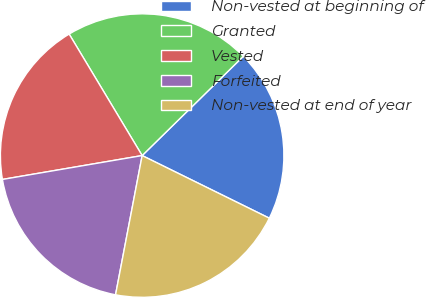Convert chart. <chart><loc_0><loc_0><loc_500><loc_500><pie_chart><fcel>Non-vested at beginning of<fcel>Granted<fcel>Vested<fcel>Forfeited<fcel>Non-vested at end of year<nl><fcel>19.63%<fcel>21.26%<fcel>19.08%<fcel>19.3%<fcel>20.72%<nl></chart> 